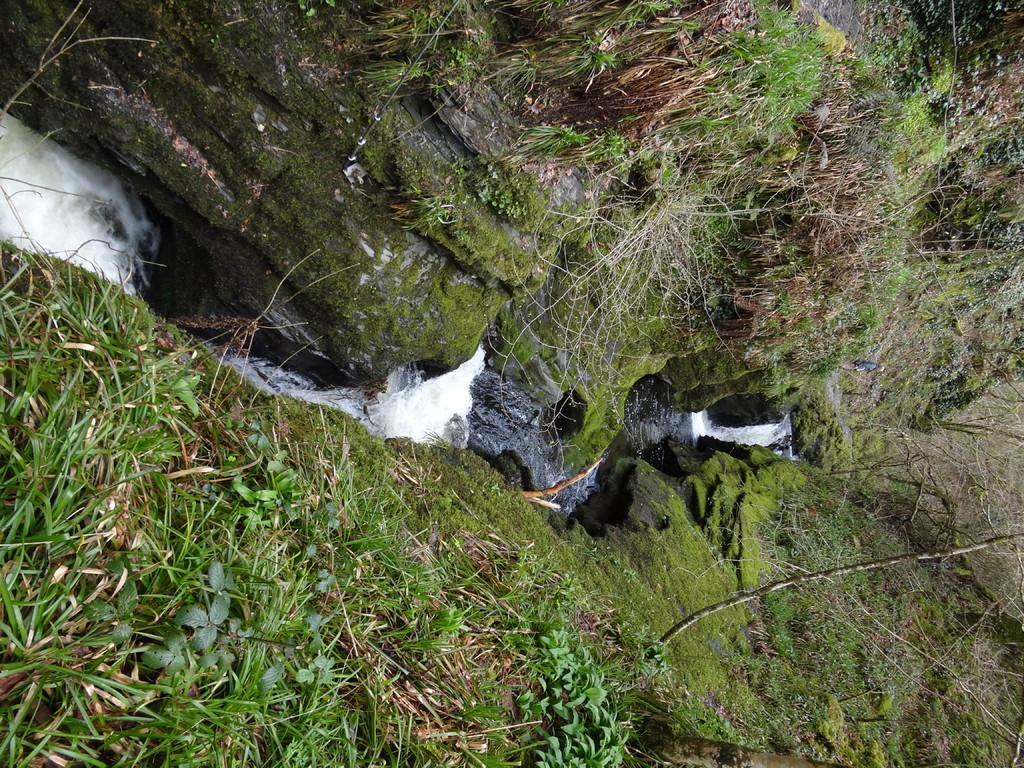Please provide a concise description of this image. In this image there are some grass in the bottom of this image and on the top of this image as well, and there is some water flowing as we can see in middle of this image, 